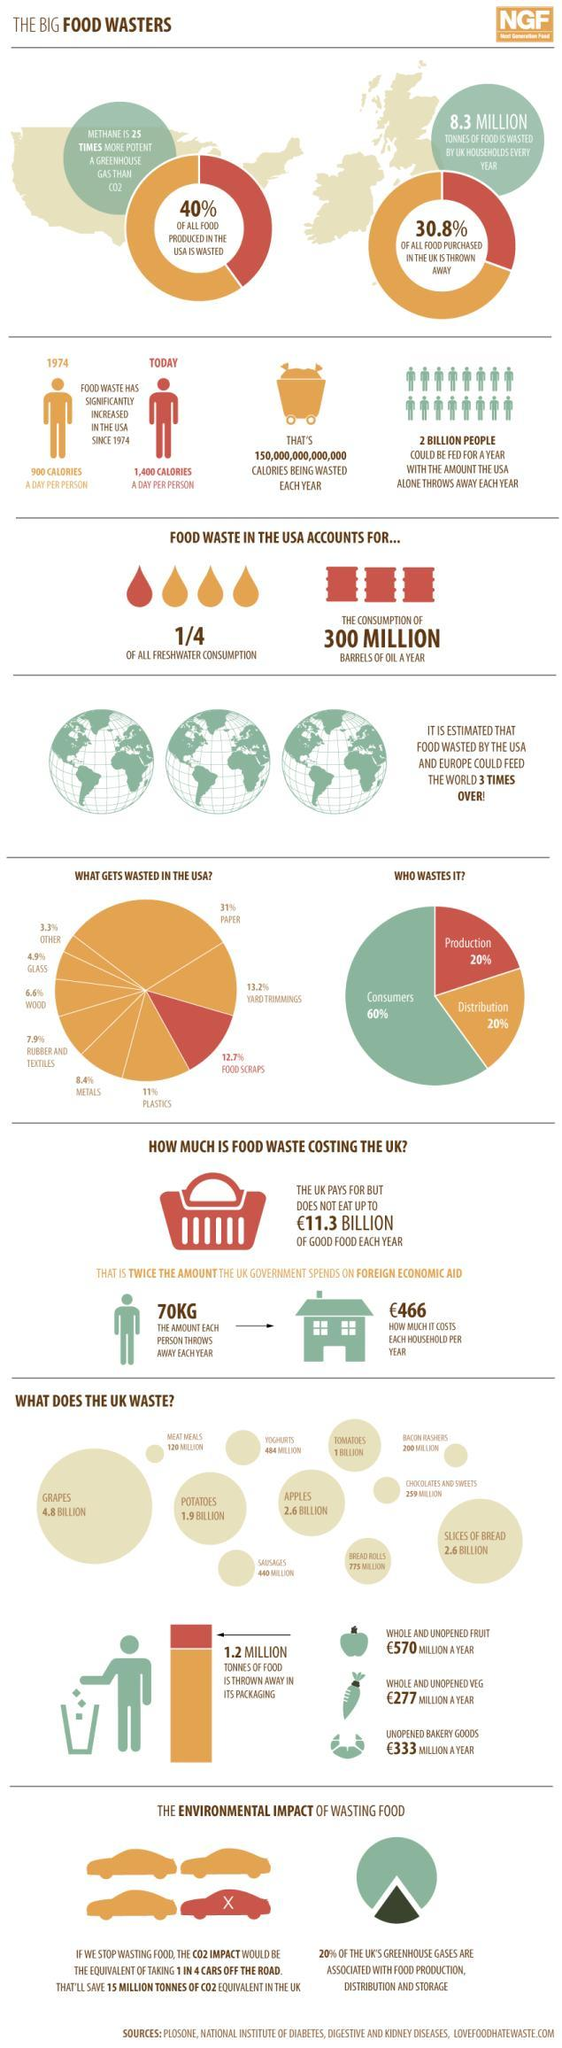What is the amount of food waste produced in a day per person in the U.S. in 1974?
Answer the question with a short phrase. 900 CALORIES Which is the most wasted food item in the UK? GRAPES What percentage is the food waste out of total wastes in the USA? 12.7% Which is the least wasted food item in the UK? MEAT MEALS What percentage of the waste is generated by the production industry in the USA? 20% What is the amount of food thrown away in a year per person in the UK? 70KG What is the quantity of bread rolls wasted in the UK? 775 MILLION How many tonnes of food is thrown away in its packing in the UK? 1.2 MILLION What percentage of the UK's greenhouse gases are not associated with food production, distribution & storage? 80% What percentage of paper waste is produced in the USA? 31% 